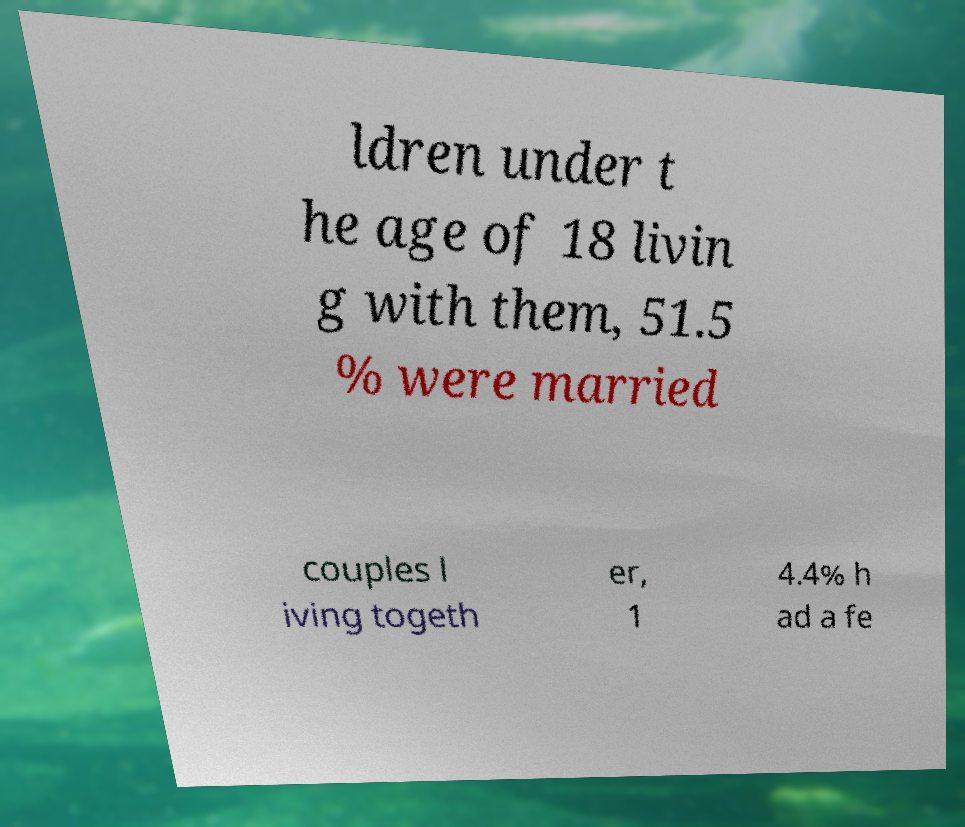I need the written content from this picture converted into text. Can you do that? ldren under t he age of 18 livin g with them, 51.5 % were married couples l iving togeth er, 1 4.4% h ad a fe 